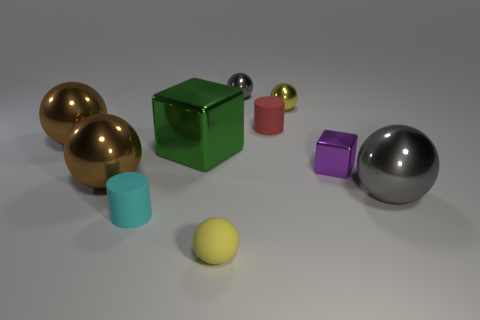Is there a matte object of the same shape as the yellow shiny thing?
Provide a succinct answer. Yes. What number of objects are either red rubber cylinders or small cylinders on the right side of the big green metallic cube?
Offer a very short reply. 1. What number of other objects are there of the same material as the tiny gray object?
Your answer should be compact. 6. How many objects are either big blocks or small gray shiny balls?
Offer a very short reply. 2. Is the number of metal spheres left of the red matte thing greater than the number of small purple cubes left of the small gray object?
Your answer should be compact. Yes. There is a large metallic thing to the right of the green thing; does it have the same color as the small metal thing that is to the left of the tiny red cylinder?
Your answer should be very brief. Yes. How big is the gray ball that is behind the big ball on the right side of the yellow sphere behind the red rubber object?
Give a very brief answer. Small. What color is the big thing that is the same shape as the small purple object?
Your answer should be very brief. Green. Is the number of tiny matte cylinders that are behind the big metallic cube greater than the number of brown matte blocks?
Your response must be concise. Yes. There is a purple shiny object; is it the same shape as the big green shiny thing that is behind the tiny shiny block?
Offer a very short reply. Yes. 